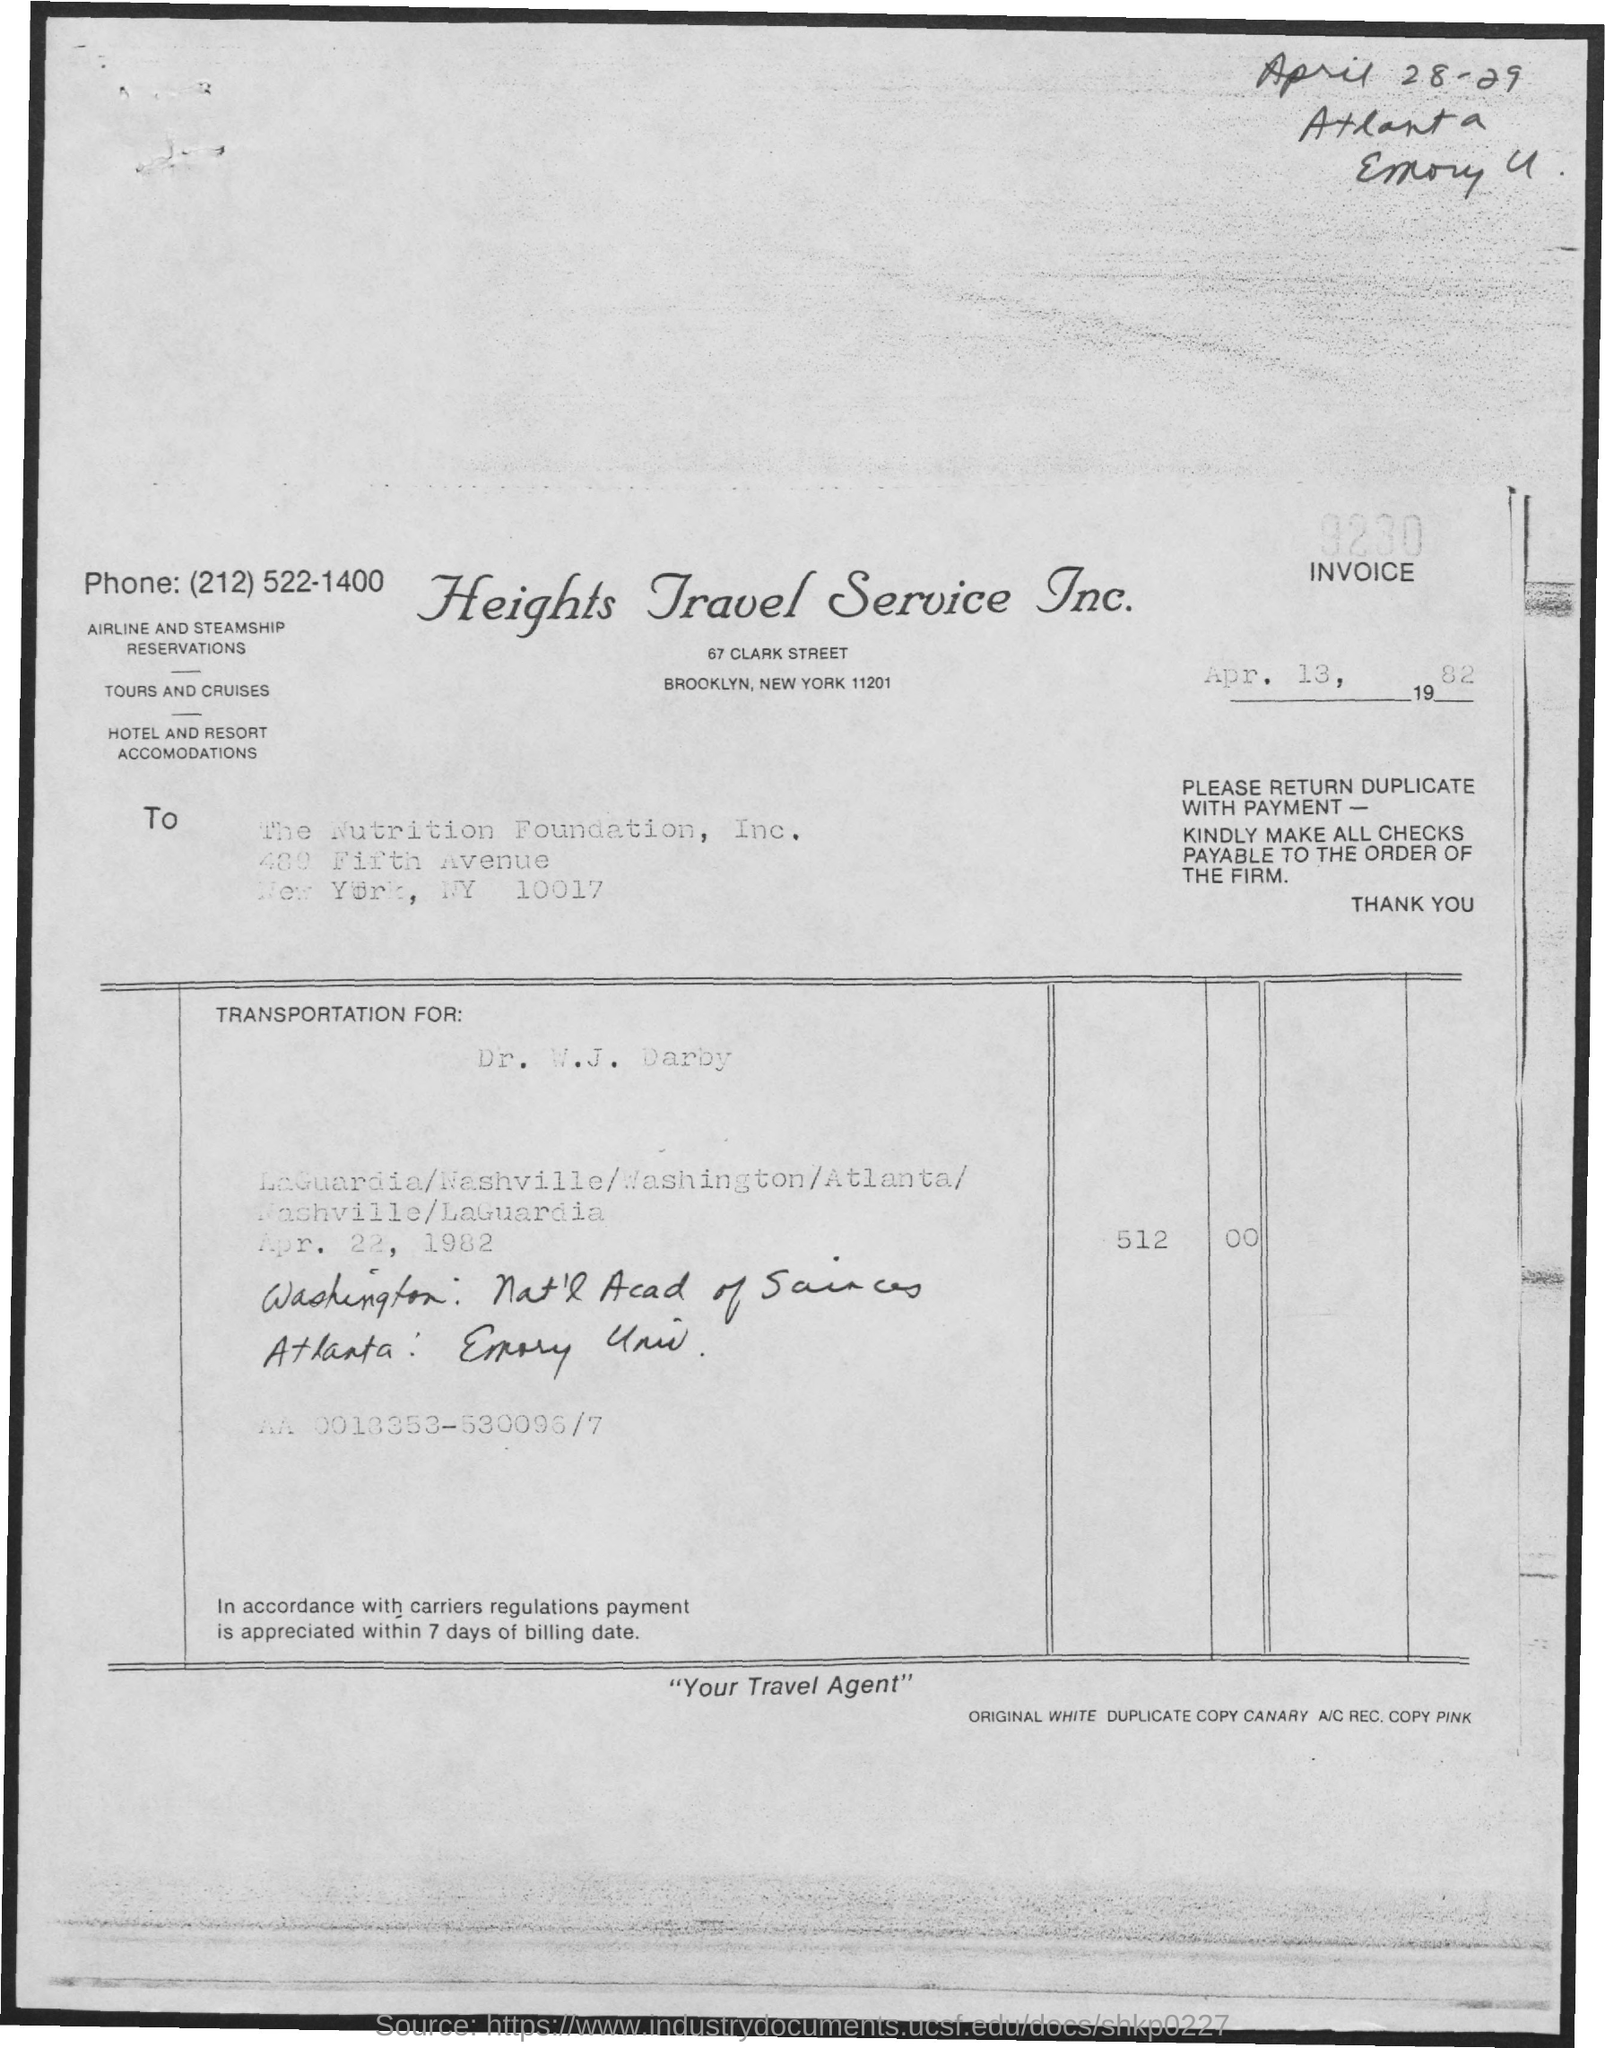Identify some key points in this picture. The date below the invoice number is April 13, 1982. The date at the top right of the document is April 28th and 29th. 